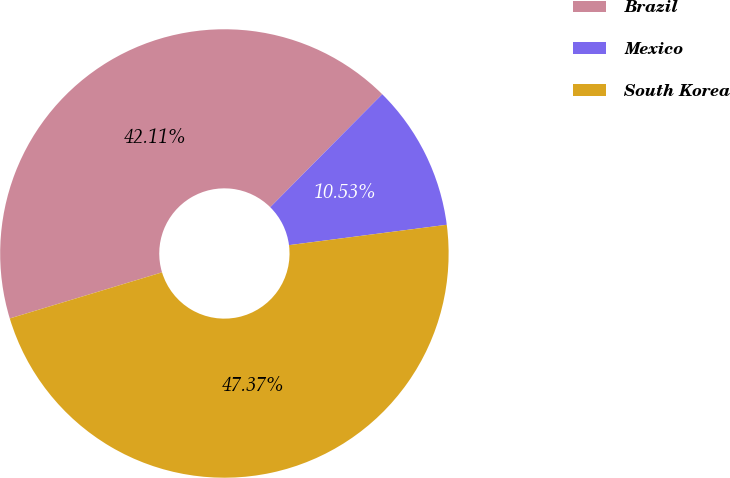Convert chart. <chart><loc_0><loc_0><loc_500><loc_500><pie_chart><fcel>Brazil<fcel>Mexico<fcel>South Korea<nl><fcel>42.11%<fcel>10.53%<fcel>47.37%<nl></chart> 